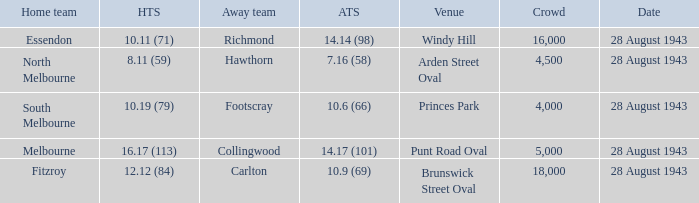Can you parse all the data within this table? {'header': ['Home team', 'HTS', 'Away team', 'ATS', 'Venue', 'Crowd', 'Date'], 'rows': [['Essendon', '10.11 (71)', 'Richmond', '14.14 (98)', 'Windy Hill', '16,000', '28 August 1943'], ['North Melbourne', '8.11 (59)', 'Hawthorn', '7.16 (58)', 'Arden Street Oval', '4,500', '28 August 1943'], ['South Melbourne', '10.19 (79)', 'Footscray', '10.6 (66)', 'Princes Park', '4,000', '28 August 1943'], ['Melbourne', '16.17 (113)', 'Collingwood', '14.17 (101)', 'Punt Road Oval', '5,000', '28 August 1943'], ['Fitzroy', '12.12 (84)', 'Carlton', '10.9 (69)', 'Brunswick Street Oval', '18,000', '28 August 1943']]} Where was the game played with an away team score of 14.17 (101)? Punt Road Oval. 